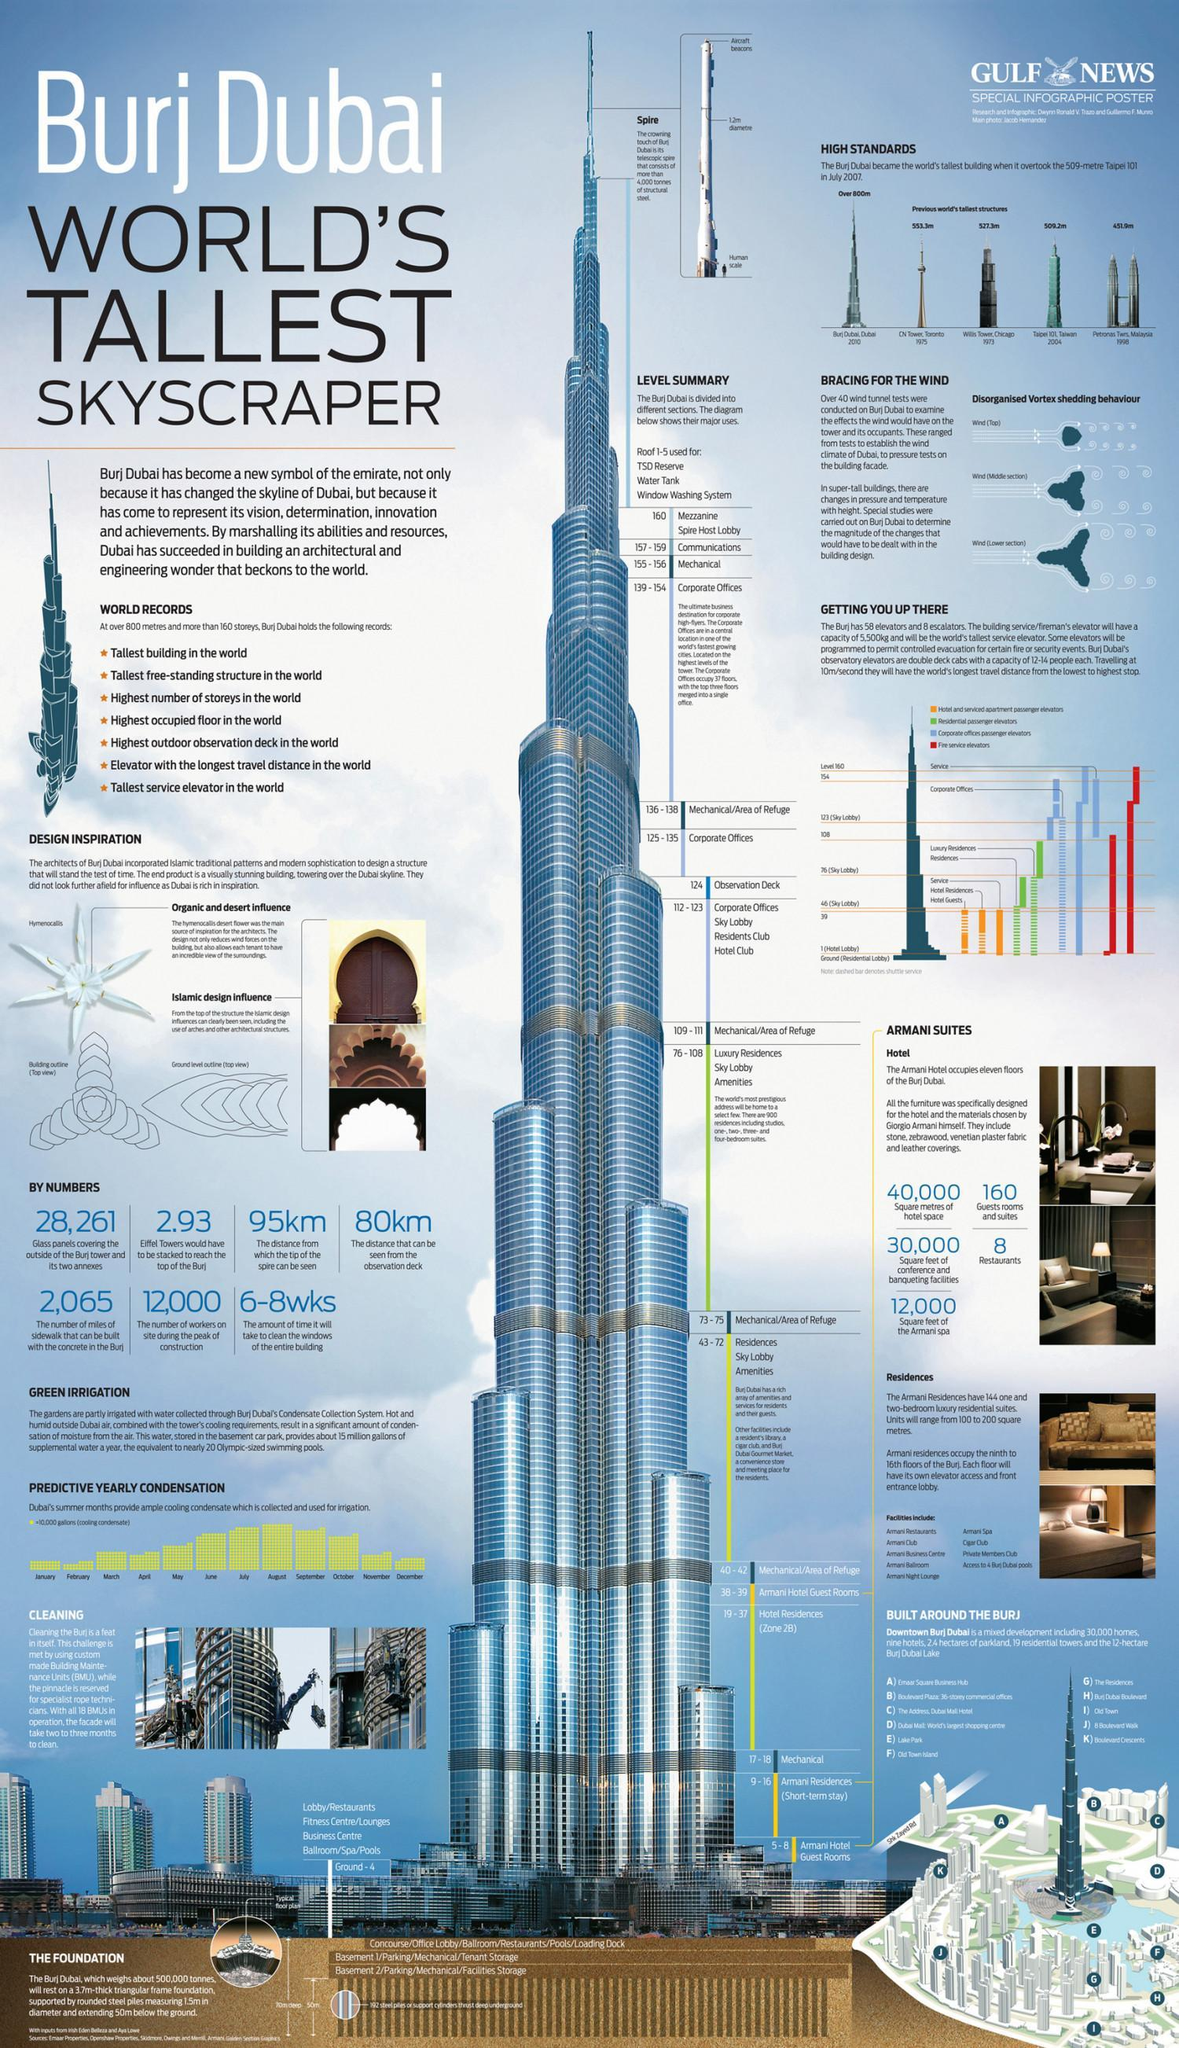What is the height of Burj Dubai?
Answer the question with a short phrase. over 800 metres Which fashion designer designed the furniture for the Armani hotel? Giorgio Armani How many guest rooms & suites in the Armani Hotel? 160 How many miles of sidewalk could be built with the concrete in the Burj? 2,065 How much time will it take to clean the windows of the entire building? 6-8wks How many workers were on site during peak phase of construction? 12,000 How many glass panels in total covering the exterior of Burj tower and its annexes? 28,261 From what distance can the tip of the spire be seen? 95km How many restaurants are there in the Armani Hotel? 8 How much distance can be seen from the observation deck? 80km 